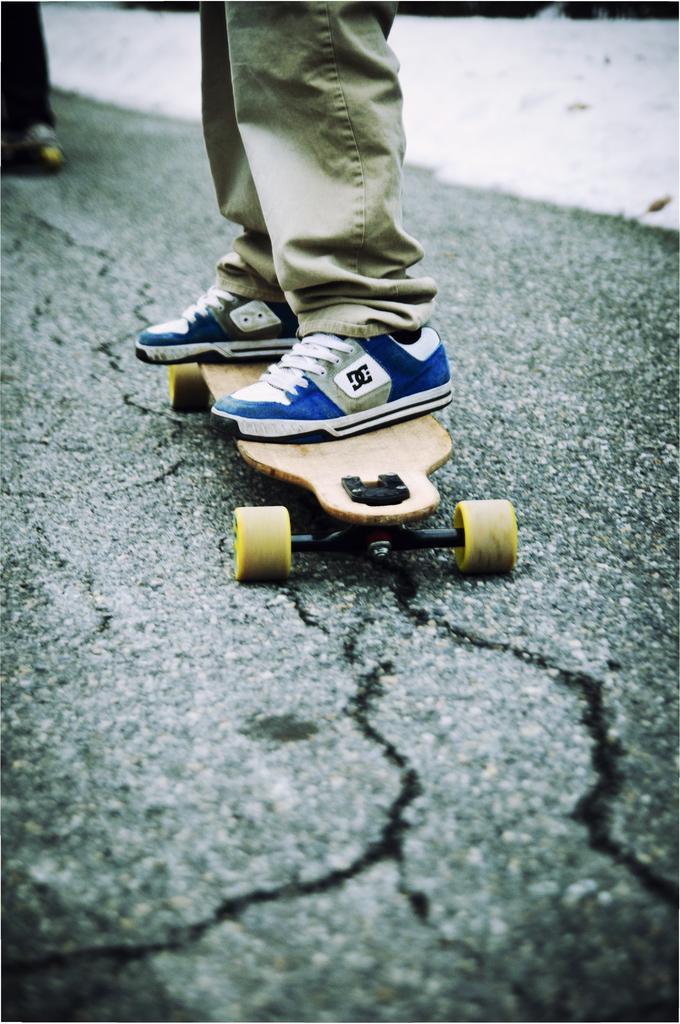Could you give a brief overview of what you see in this image? A person wore trouser, shoes and standing on the skate board on the road. 